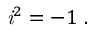<formula> <loc_0><loc_0><loc_500><loc_500>{ i } ^ { 2 } = - 1 \ .</formula> 